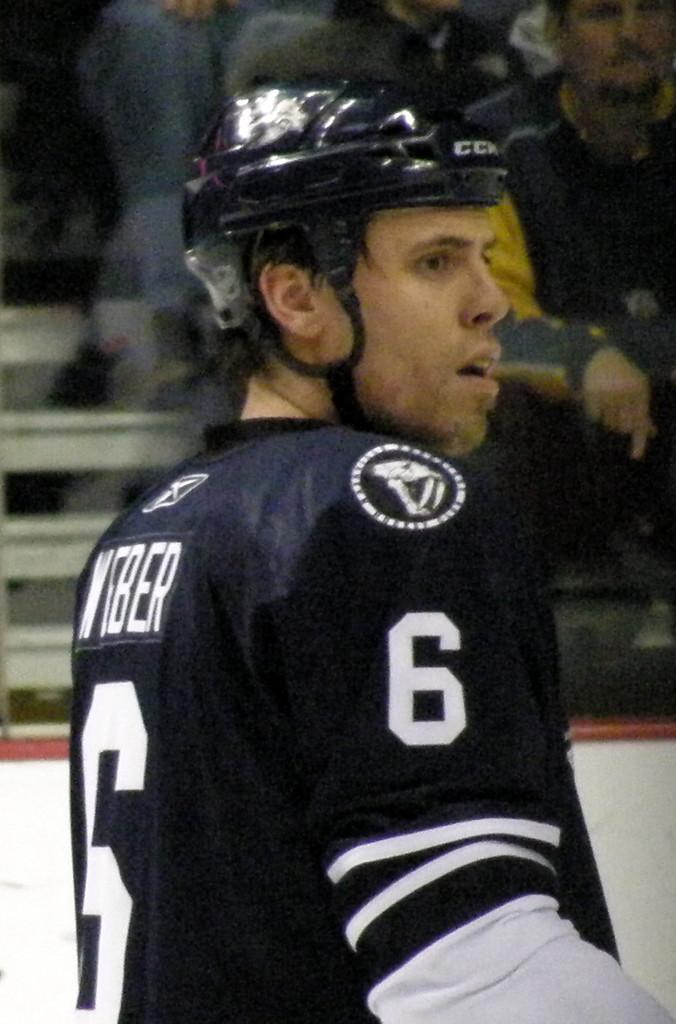What is the main subject of the picture? The main subject of the picture is a man. What is the man wearing on his head? The man is wearing a helmet. What is the man wearing on his body? The man is wearing a jersey with the number 6 on it. What can be seen in the background of the image? There is a group of persons sitting on the stairs in the background of the image. What are the group of persons doing? The group of persons is watching a game. What country is the man from, based on the image? There is no information in the image to determine the man's country of origin. What trade does the man practice, as seen in the image? There is no indication of the man's occupation or trade in the image. 